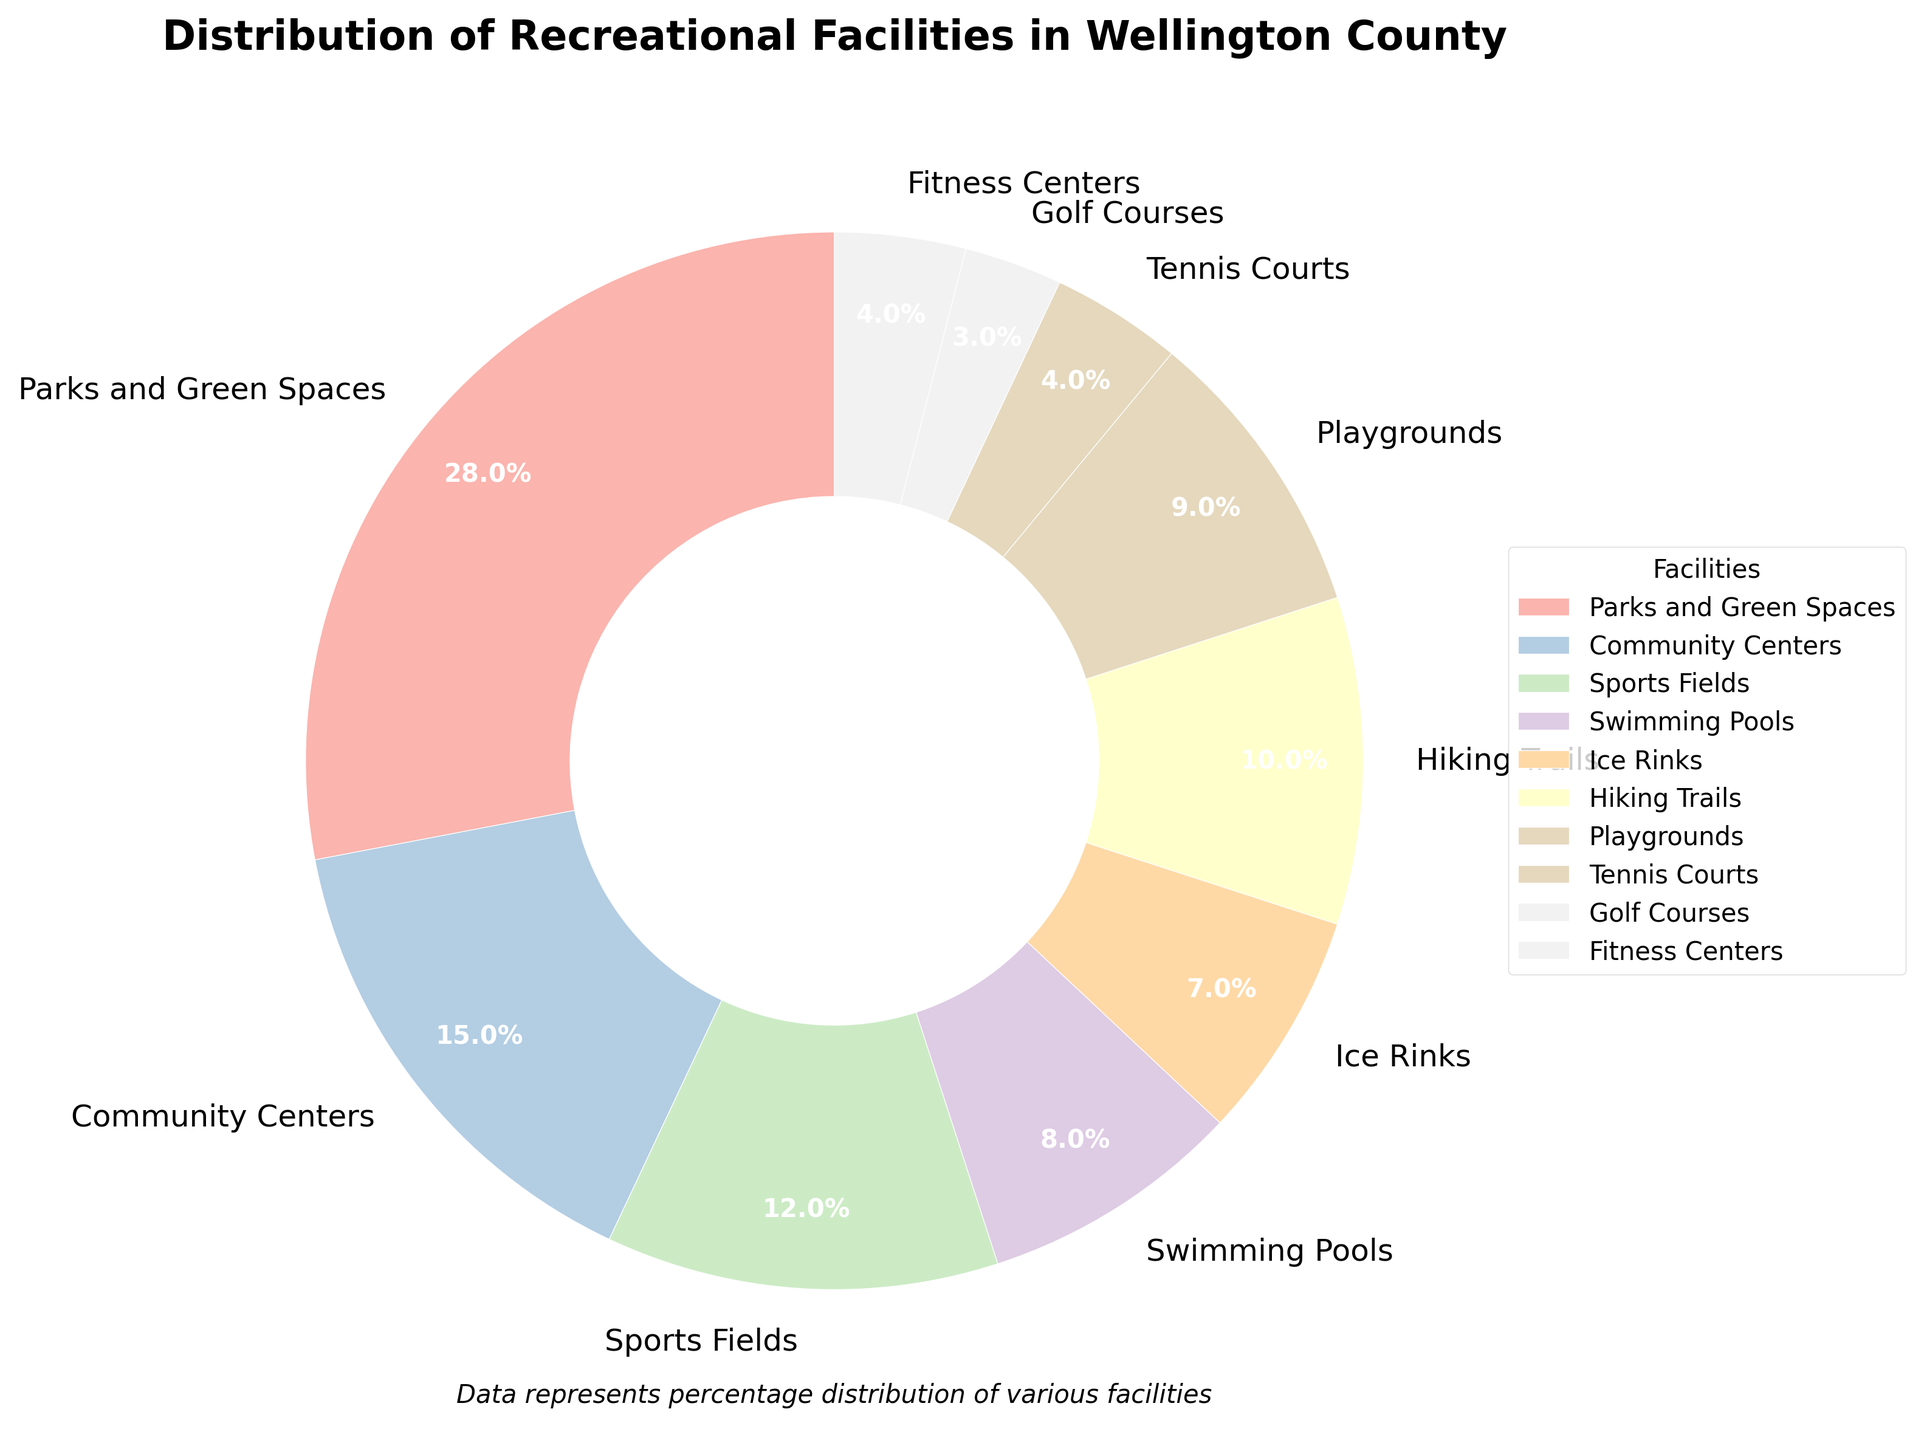What's the total percentage of facilities dedicated to sports (Sports Fields, Ice Rinks, Tennis Courts, Golf Courses, Fitness Centers)? To find the total percentage dedicated to sports, sum the percentages of Sports Fields (12%), Ice Rinks (7%), Tennis Courts (4%), Golf Courses (3%), and Fitness Centers (4%). The calculation is 12 + 7 + 4 + 3 + 4 = 30%.
Answer: 30 Which category has the highest percentage? By looking at the pie chart, the largest section is Parks and Green Spaces, which occupies 28% of the facilities.
Answer: Parks and Green Spaces Which facility categories have less than 5% each? Observing the pie chart, the sections representing Tennis Courts (4%) and Golf Courses (3%) are each less than 5%.
Answer: Tennis Courts and Golf Courses What is the percentage difference between the largest and smallest facility categories? The largest category is Parks and Green Spaces (28%) and the smallest is Golf Courses (3%). The difference is calculated as 28 - 3 = 25%.
Answer: 25 What is the combined percentage of Parks and Green Spaces, and Hiking Trails? Add the percentages of Parks and Green Spaces (28%) and Hiking Trails (10%). The calculation is 28 + 10 = 38%.
Answer: 38 Are there any facility categories that have equal percentages? Upon examining the pie chart, we find that both Tennis Courts and Fitness Centers have the same percentage of 4%.
Answer: Tennis Courts and Fitness Centers Compare the percentage of Community Centers and Playgrounds. Which one has a higher percentage and by how much? Community Centers have 15% while Playgrounds have 9%. The difference is calculated as 15 - 9 = 6%. Community Centers have a higher percentage.
Answer: Community Centers by 6 What's the sum of the percentages of Community Centers, Swimming Pools, and Ice Rinks? Sum the percentages of Community Centers (15%), Swimming Pools (8%), and Ice Rinks (7%). The calculation is 15 + 8 + 7 = 30%.
Answer: 30 If we group Playgrounds and Playground-related categories (Parks and Green Spaces, Playgrounds) together, what percentage of the facilities do they represent? Sum the percentages of Parks and Green Spaces (28%) and Playgrounds (9%). The calculation is 28 + 9 = 37%.
Answer: 37 Which category, between Swimming Pools and Hiking Trails, has a smaller percentage and by how much? Swimming Pools have 8% while Hiking Trails have 10%. The difference is calculated as 10 - 8 = 2%. Swimming Pools have a smaller percentage.
Answer: Swimming Pools by 2 